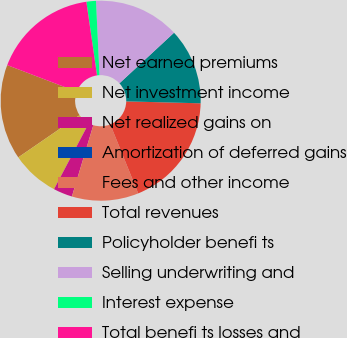<chart> <loc_0><loc_0><loc_500><loc_500><pie_chart><fcel>Net earned premiums<fcel>Net investment income<fcel>Net realized gains on<fcel>Amortization of deferred gains<fcel>Fees and other income<fcel>Total revenues<fcel>Policyholder benefi ts<fcel>Selling underwriting and<fcel>Interest expense<fcel>Total benefi ts losses and<nl><fcel>15.38%<fcel>7.69%<fcel>3.08%<fcel>0.0%<fcel>10.77%<fcel>18.46%<fcel>12.31%<fcel>13.85%<fcel>1.54%<fcel>16.92%<nl></chart> 